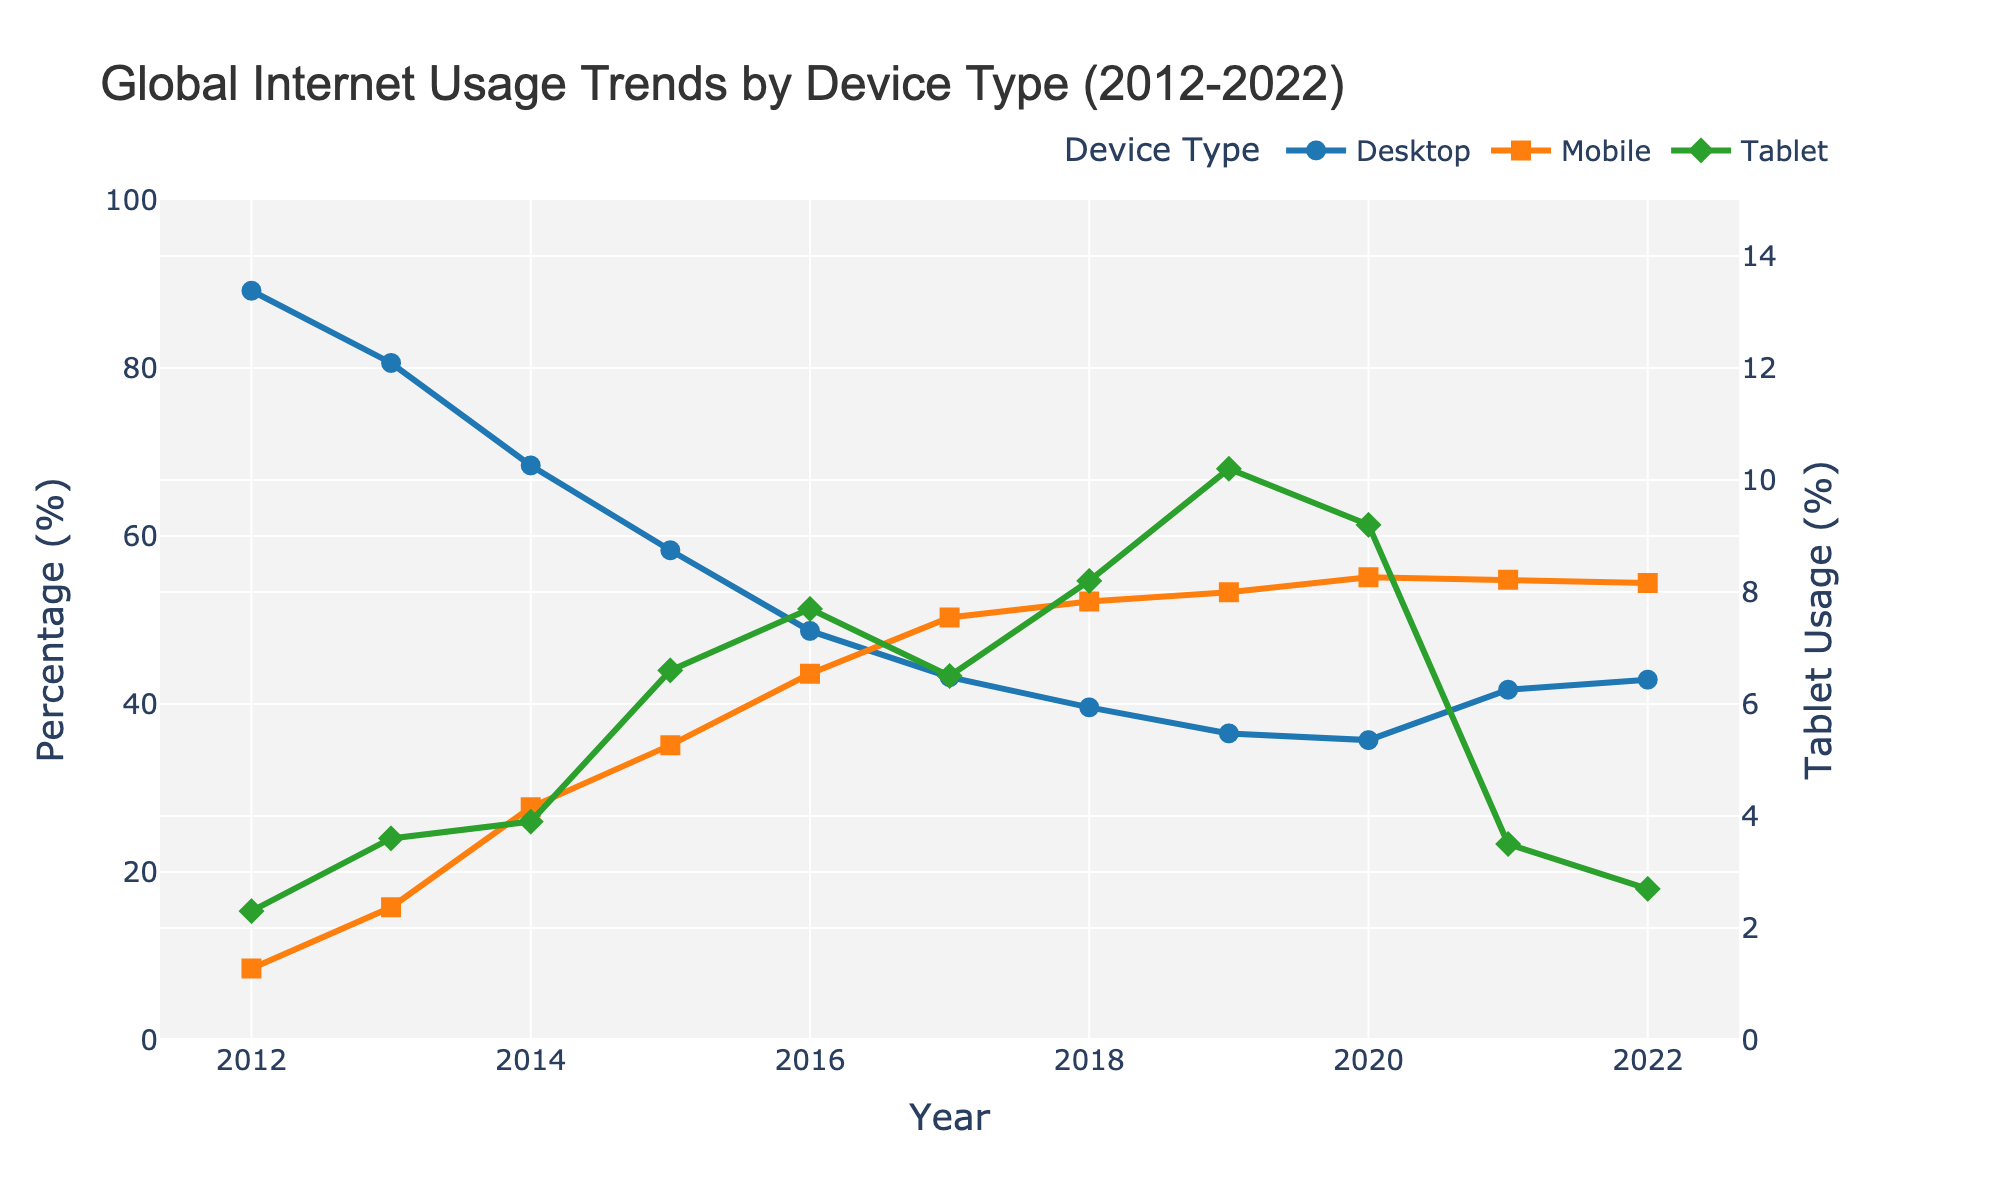what trend is observed for Mobile internet usage over the period 2012 to 2022? The Mobile internet usage shows a general increasing trend from 8.5% in 2012 to 54.4% in 2022. A rapid increase is observed till 2019, with a slight decrease in 2022.
Answer: Increasing trend In which year did Desktop internet usage drop below 50% for the first time? Desktop internet usage dropped below 50% for the first time in 2016, from 58.3% in 2015 to 48.7% in 2016.
Answer: 2016 Compare the usage percentages of Desktop and Mobile in 2021. Which one has a higher usage? In 2021, Desktop usage was 41.7% while Mobile usage was 54.8%. Therefore, Mobile has a higher usage percentage.
Answer: Mobile What is the percentage increase in Mobile internet usage from 2012 to 2014? In 2012, Mobile internet usage was 8.5%. In 2014, it was 27.7%. The percentage increase is calculated as ((27.7 - 8.5) / 8.5) * 100 = 225.9%.
Answer: 225.9% Which device type shows the most consistent usage trend over the decade? Tablet shows a relatively consistent trend with minor fluctuations. It increases from 2.3% in 2012 to a peak in 2019 and then drops sharply from 2020 to 2022.
Answer: Tablet What is the difference in Desktop and Mobile usage percentages in the year 2017? In 2017, Desktop usage was 43.2% and Mobile usage was 50.3%. The difference is calculated as 50.3% - 43.2% = 7.1%.
Answer: 7.1% During which year did Tablet usage peak, and what was the percentage? Tablet usage peaked in 2019 at 10.2%.
Answer: 2019, 10.2% Calculate the average Desktop internet usage from 2012 to 2022. To calculate the average: (89.2 + 80.6 + 68.4 + 58.3 + 48.7 + 43.2 + 39.6 + 36.5 + 35.7 + 41.7 + 42.9) / 11. Summing these gives 585.8, and dividing by 11 yields approximately 53.26%.
Answer: 53.26% In which year did the combined usage percentage of Desktop and Tablet drop below 50%? The combined usage of Desktop and Tablet dropped below 50% in the year 2021. In that year, Desktop usage was 41.7% and Tablet was 3.5%, combining to 45.2%.
Answer: 2021 